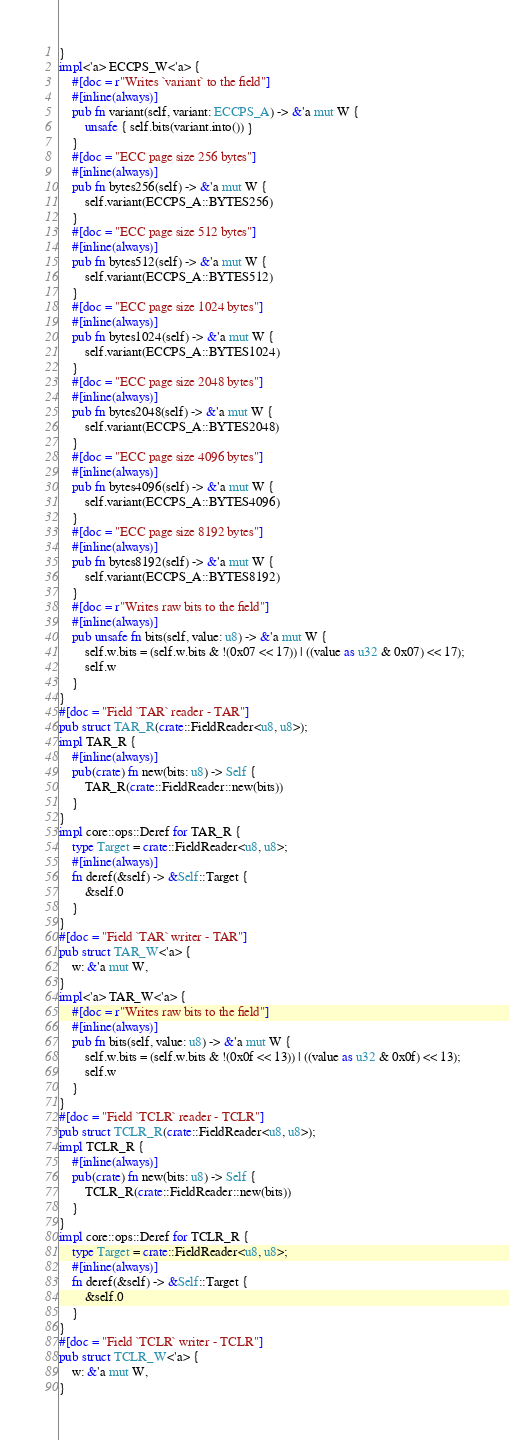Convert code to text. <code><loc_0><loc_0><loc_500><loc_500><_Rust_>}
impl<'a> ECCPS_W<'a> {
    #[doc = r"Writes `variant` to the field"]
    #[inline(always)]
    pub fn variant(self, variant: ECCPS_A) -> &'a mut W {
        unsafe { self.bits(variant.into()) }
    }
    #[doc = "ECC page size 256 bytes"]
    #[inline(always)]
    pub fn bytes256(self) -> &'a mut W {
        self.variant(ECCPS_A::BYTES256)
    }
    #[doc = "ECC page size 512 bytes"]
    #[inline(always)]
    pub fn bytes512(self) -> &'a mut W {
        self.variant(ECCPS_A::BYTES512)
    }
    #[doc = "ECC page size 1024 bytes"]
    #[inline(always)]
    pub fn bytes1024(self) -> &'a mut W {
        self.variant(ECCPS_A::BYTES1024)
    }
    #[doc = "ECC page size 2048 bytes"]
    #[inline(always)]
    pub fn bytes2048(self) -> &'a mut W {
        self.variant(ECCPS_A::BYTES2048)
    }
    #[doc = "ECC page size 4096 bytes"]
    #[inline(always)]
    pub fn bytes4096(self) -> &'a mut W {
        self.variant(ECCPS_A::BYTES4096)
    }
    #[doc = "ECC page size 8192 bytes"]
    #[inline(always)]
    pub fn bytes8192(self) -> &'a mut W {
        self.variant(ECCPS_A::BYTES8192)
    }
    #[doc = r"Writes raw bits to the field"]
    #[inline(always)]
    pub unsafe fn bits(self, value: u8) -> &'a mut W {
        self.w.bits = (self.w.bits & !(0x07 << 17)) | ((value as u32 & 0x07) << 17);
        self.w
    }
}
#[doc = "Field `TAR` reader - TAR"]
pub struct TAR_R(crate::FieldReader<u8, u8>);
impl TAR_R {
    #[inline(always)]
    pub(crate) fn new(bits: u8) -> Self {
        TAR_R(crate::FieldReader::new(bits))
    }
}
impl core::ops::Deref for TAR_R {
    type Target = crate::FieldReader<u8, u8>;
    #[inline(always)]
    fn deref(&self) -> &Self::Target {
        &self.0
    }
}
#[doc = "Field `TAR` writer - TAR"]
pub struct TAR_W<'a> {
    w: &'a mut W,
}
impl<'a> TAR_W<'a> {
    #[doc = r"Writes raw bits to the field"]
    #[inline(always)]
    pub fn bits(self, value: u8) -> &'a mut W {
        self.w.bits = (self.w.bits & !(0x0f << 13)) | ((value as u32 & 0x0f) << 13);
        self.w
    }
}
#[doc = "Field `TCLR` reader - TCLR"]
pub struct TCLR_R(crate::FieldReader<u8, u8>);
impl TCLR_R {
    #[inline(always)]
    pub(crate) fn new(bits: u8) -> Self {
        TCLR_R(crate::FieldReader::new(bits))
    }
}
impl core::ops::Deref for TCLR_R {
    type Target = crate::FieldReader<u8, u8>;
    #[inline(always)]
    fn deref(&self) -> &Self::Target {
        &self.0
    }
}
#[doc = "Field `TCLR` writer - TCLR"]
pub struct TCLR_W<'a> {
    w: &'a mut W,
}</code> 